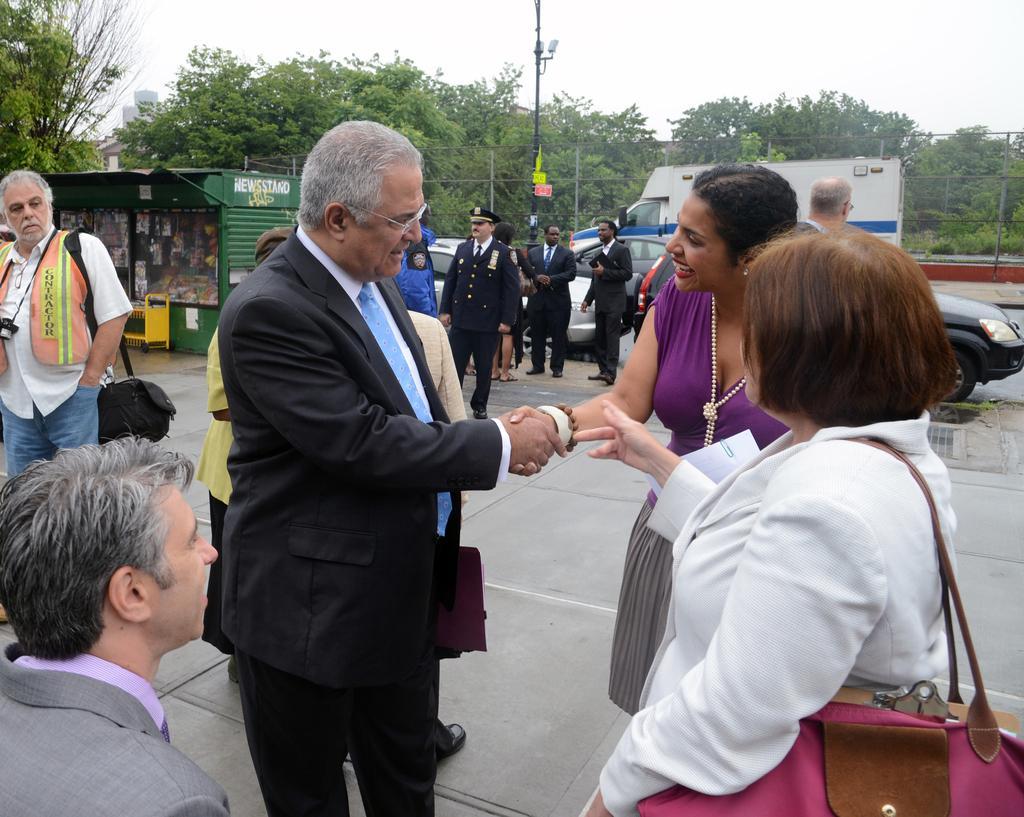Can you describe this image briefly? In this image in front there are two people shaking their hands. Beside them there are a few other people. Behind them there are cars. In front of the cars there are people. In the background of the image there are stalls, trees. There are poles. At the top of the image there is sky. 